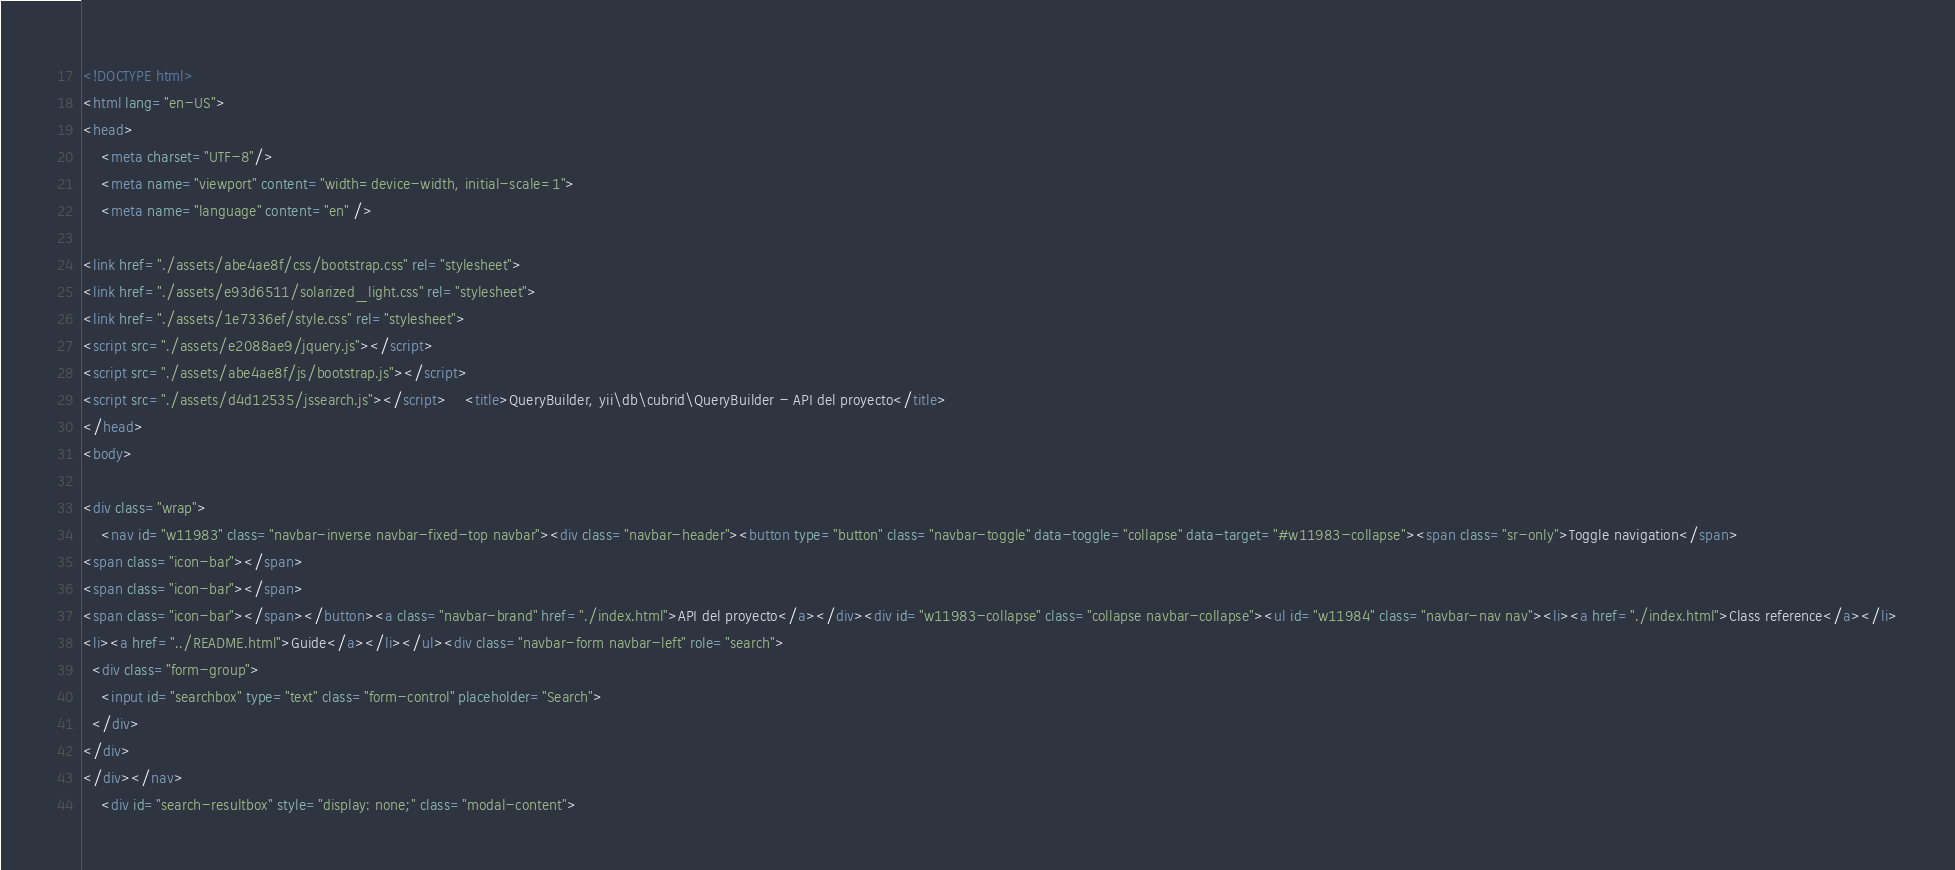<code> <loc_0><loc_0><loc_500><loc_500><_HTML_><!DOCTYPE html>
<html lang="en-US">
<head>
    <meta charset="UTF-8"/>
    <meta name="viewport" content="width=device-width, initial-scale=1">
    <meta name="language" content="en" />
        
<link href="./assets/abe4ae8f/css/bootstrap.css" rel="stylesheet">
<link href="./assets/e93d6511/solarized_light.css" rel="stylesheet">
<link href="./assets/1e7336ef/style.css" rel="stylesheet">
<script src="./assets/e2088ae9/jquery.js"></script>
<script src="./assets/abe4ae8f/js/bootstrap.js"></script>
<script src="./assets/d4d12535/jssearch.js"></script>    <title>QueryBuilder, yii\db\cubrid\QueryBuilder - API del proyecto</title>
</head>
<body>

<div class="wrap">
    <nav id="w11983" class="navbar-inverse navbar-fixed-top navbar"><div class="navbar-header"><button type="button" class="navbar-toggle" data-toggle="collapse" data-target="#w11983-collapse"><span class="sr-only">Toggle navigation</span>
<span class="icon-bar"></span>
<span class="icon-bar"></span>
<span class="icon-bar"></span></button><a class="navbar-brand" href="./index.html">API del proyecto</a></div><div id="w11983-collapse" class="collapse navbar-collapse"><ul id="w11984" class="navbar-nav nav"><li><a href="./index.html">Class reference</a></li>
<li><a href="../README.html">Guide</a></li></ul><div class="navbar-form navbar-left" role="search">
  <div class="form-group">
    <input id="searchbox" type="text" class="form-control" placeholder="Search">
  </div>
</div>
</div></nav>
    <div id="search-resultbox" style="display: none;" class="modal-content"></code> 